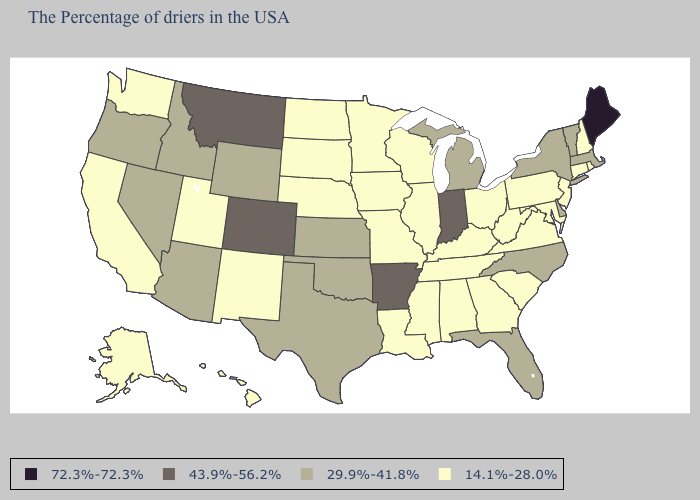Among the states that border Arkansas , does Tennessee have the highest value?
Quick response, please. No. Among the states that border South Carolina , which have the lowest value?
Concise answer only. Georgia. What is the value of Massachusetts?
Keep it brief. 29.9%-41.8%. Does Maine have the highest value in the USA?
Short answer required. Yes. Name the states that have a value in the range 14.1%-28.0%?
Be succinct. Rhode Island, New Hampshire, Connecticut, New Jersey, Maryland, Pennsylvania, Virginia, South Carolina, West Virginia, Ohio, Georgia, Kentucky, Alabama, Tennessee, Wisconsin, Illinois, Mississippi, Louisiana, Missouri, Minnesota, Iowa, Nebraska, South Dakota, North Dakota, New Mexico, Utah, California, Washington, Alaska, Hawaii. What is the value of Idaho?
Be succinct. 29.9%-41.8%. What is the highest value in the West ?
Quick response, please. 43.9%-56.2%. Name the states that have a value in the range 43.9%-56.2%?
Be succinct. Indiana, Arkansas, Colorado, Montana. Does Virginia have the highest value in the South?
Be succinct. No. Does the map have missing data?
Give a very brief answer. No. What is the lowest value in the USA?
Be succinct. 14.1%-28.0%. What is the value of Idaho?
Concise answer only. 29.9%-41.8%. What is the highest value in the West ?
Quick response, please. 43.9%-56.2%. Name the states that have a value in the range 72.3%-72.3%?
Be succinct. Maine. What is the value of Maryland?
Give a very brief answer. 14.1%-28.0%. 